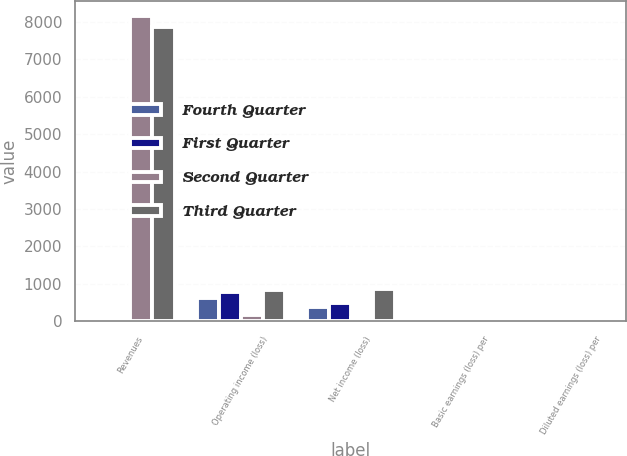<chart> <loc_0><loc_0><loc_500><loc_500><stacked_bar_chart><ecel><fcel>Revenues<fcel>Operating income (loss)<fcel>Net income (loss)<fcel>Basic earnings (loss) per<fcel>Diluted earnings (loss) per<nl><fcel>Fourth Quarter<fcel>2.82<fcel>630<fcel>384<fcel>1.23<fcel>1.58<nl><fcel>First Quarter<fcel>2.82<fcel>784<fcel>493<fcel>1.59<fcel>1.54<nl><fcel>Second Quarter<fcel>8137<fcel>182<fcel>97<fcel>0.31<fcel>1.26<nl><fcel>Third Quarter<fcel>7852<fcel>849<fcel>876<fcel>2.82<fcel>0.78<nl></chart> 